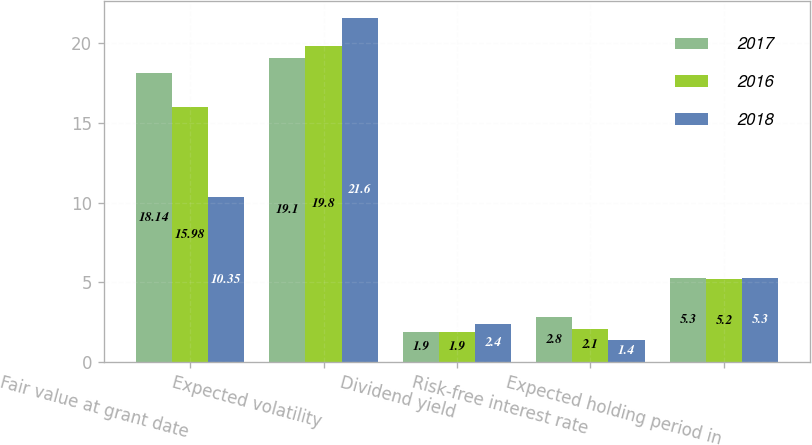<chart> <loc_0><loc_0><loc_500><loc_500><stacked_bar_chart><ecel><fcel>Fair value at grant date<fcel>Expected volatility<fcel>Dividend yield<fcel>Risk-free interest rate<fcel>Expected holding period in<nl><fcel>2017<fcel>18.14<fcel>19.1<fcel>1.9<fcel>2.8<fcel>5.3<nl><fcel>2016<fcel>15.98<fcel>19.8<fcel>1.9<fcel>2.1<fcel>5.2<nl><fcel>2018<fcel>10.35<fcel>21.6<fcel>2.4<fcel>1.4<fcel>5.3<nl></chart> 